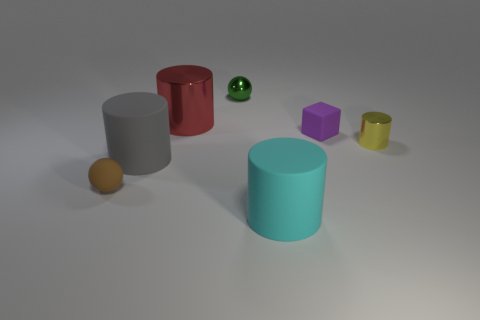Subtract all tiny yellow metallic cylinders. How many cylinders are left? 3 Subtract all red cylinders. How many cylinders are left? 3 Subtract all balls. How many objects are left? 5 Subtract all purple blocks. How many brown cylinders are left? 0 Subtract all small red metallic cubes. Subtract all tiny spheres. How many objects are left? 5 Add 4 tiny metal spheres. How many tiny metal spheres are left? 5 Add 3 green objects. How many green objects exist? 4 Add 1 small green things. How many objects exist? 8 Subtract 0 purple cylinders. How many objects are left? 7 Subtract 1 blocks. How many blocks are left? 0 